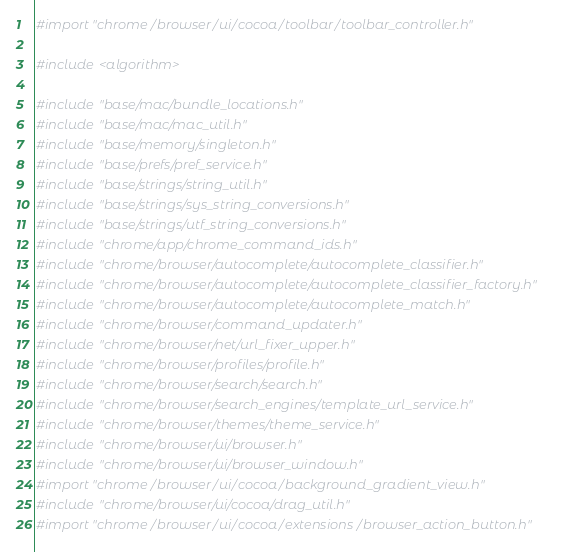Convert code to text. <code><loc_0><loc_0><loc_500><loc_500><_ObjectiveC_>
#import "chrome/browser/ui/cocoa/toolbar/toolbar_controller.h"

#include <algorithm>

#include "base/mac/bundle_locations.h"
#include "base/mac/mac_util.h"
#include "base/memory/singleton.h"
#include "base/prefs/pref_service.h"
#include "base/strings/string_util.h"
#include "base/strings/sys_string_conversions.h"
#include "base/strings/utf_string_conversions.h"
#include "chrome/app/chrome_command_ids.h"
#include "chrome/browser/autocomplete/autocomplete_classifier.h"
#include "chrome/browser/autocomplete/autocomplete_classifier_factory.h"
#include "chrome/browser/autocomplete/autocomplete_match.h"
#include "chrome/browser/command_updater.h"
#include "chrome/browser/net/url_fixer_upper.h"
#include "chrome/browser/profiles/profile.h"
#include "chrome/browser/search/search.h"
#include "chrome/browser/search_engines/template_url_service.h"
#include "chrome/browser/themes/theme_service.h"
#include "chrome/browser/ui/browser.h"
#include "chrome/browser/ui/browser_window.h"
#import "chrome/browser/ui/cocoa/background_gradient_view.h"
#include "chrome/browser/ui/cocoa/drag_util.h"
#import "chrome/browser/ui/cocoa/extensions/browser_action_button.h"</code> 